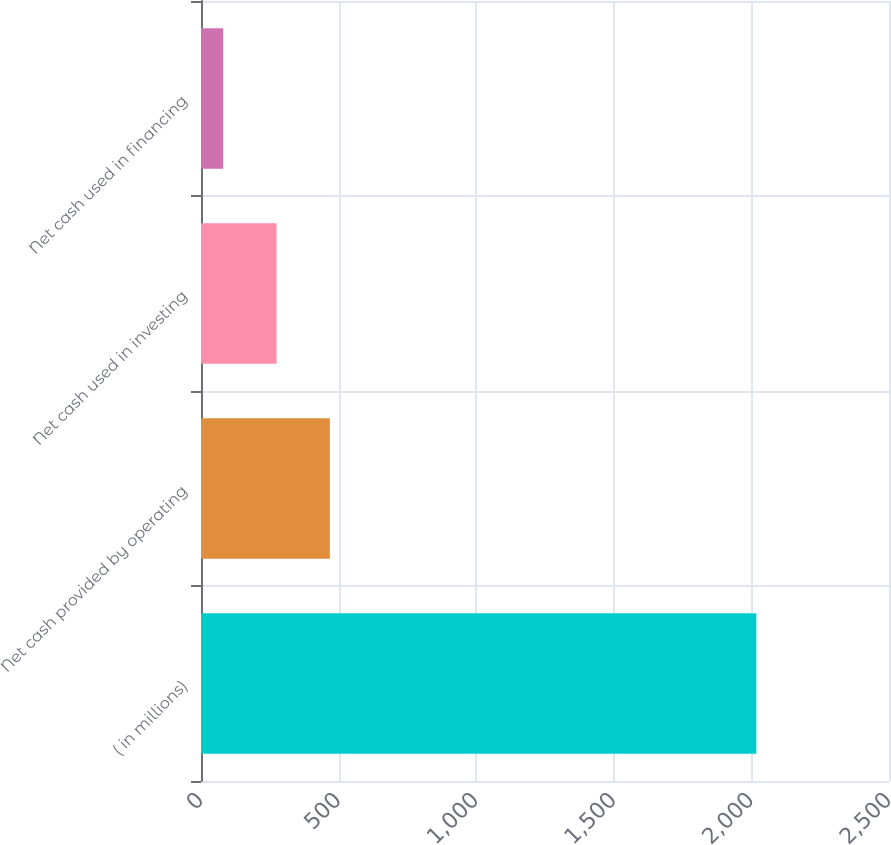<chart> <loc_0><loc_0><loc_500><loc_500><bar_chart><fcel>( in millions)<fcel>Net cash provided by operating<fcel>Net cash used in investing<fcel>Net cash used in financing<nl><fcel>2018<fcel>468.16<fcel>274.43<fcel>80.7<nl></chart> 